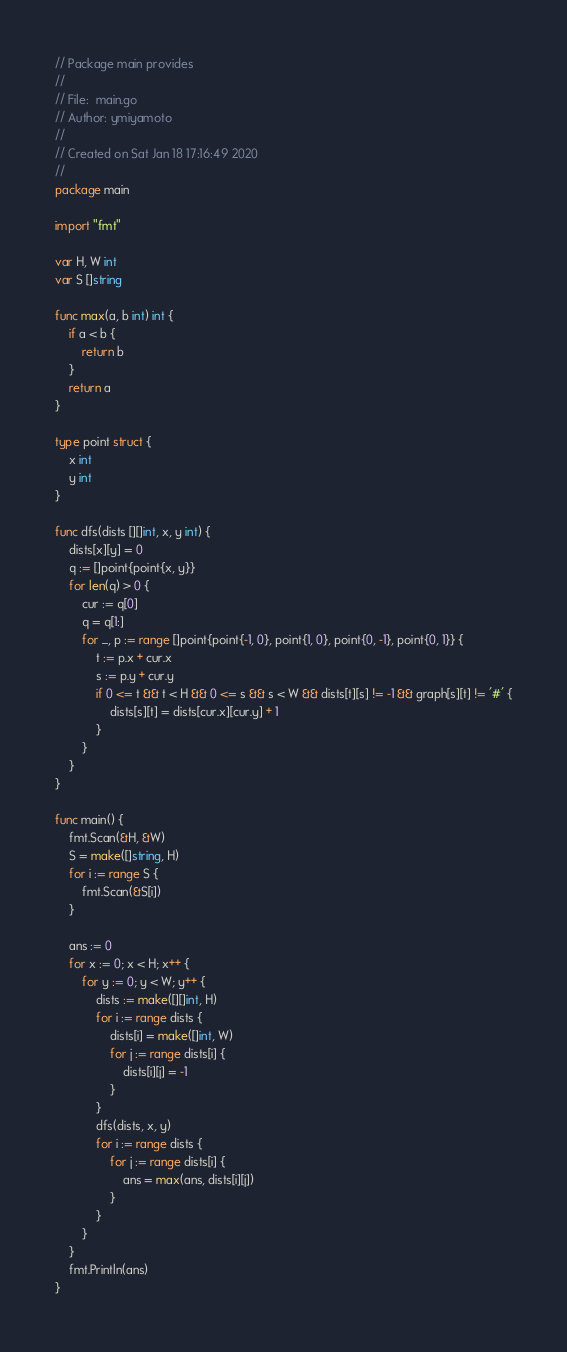Convert code to text. <code><loc_0><loc_0><loc_500><loc_500><_Go_>// Package main provides
//
// File:  main.go
// Author: ymiyamoto
//
// Created on Sat Jan 18 17:16:49 2020
//
package main

import "fmt"

var H, W int
var S []string

func max(a, b int) int {
	if a < b {
		return b
	}
	return a
}

type point struct {
	x int
	y int
}

func dfs(dists [][]int, x, y int) {
	dists[x][y] = 0
	q := []point{point{x, y}}
	for len(q) > 0 {
		cur := q[0]
		q = q[1:]
		for _, p := range []point{point{-1, 0}, point{1, 0}, point{0, -1}, point{0, 1}} {
			t := p.x + cur.x
			s := p.y + cur.y
			if 0 <= t && t < H && 0 <= s && s < W && dists[t][s] != -1 && graph[s][t] != '#' {
				dists[s][t] = dists[cur.x][cur.y] + 1
			}
		}
	}
}

func main() {
	fmt.Scan(&H, &W)
	S = make([]string, H)
	for i := range S {
		fmt.Scan(&S[i])
	}

	ans := 0
	for x := 0; x < H; x++ {
		for y := 0; y < W; y++ {
			dists := make([][]int, H)
			for i := range dists {
				dists[i] = make([]int, W)
				for j := range dists[i] {
					dists[i][j] = -1
				}
			}
			dfs(dists, x, y)
			for i := range dists {
				for j := range dists[i] {
					ans = max(ans, dists[i][j])
				}
			}
		}
	}
	fmt.Println(ans)
}
</code> 